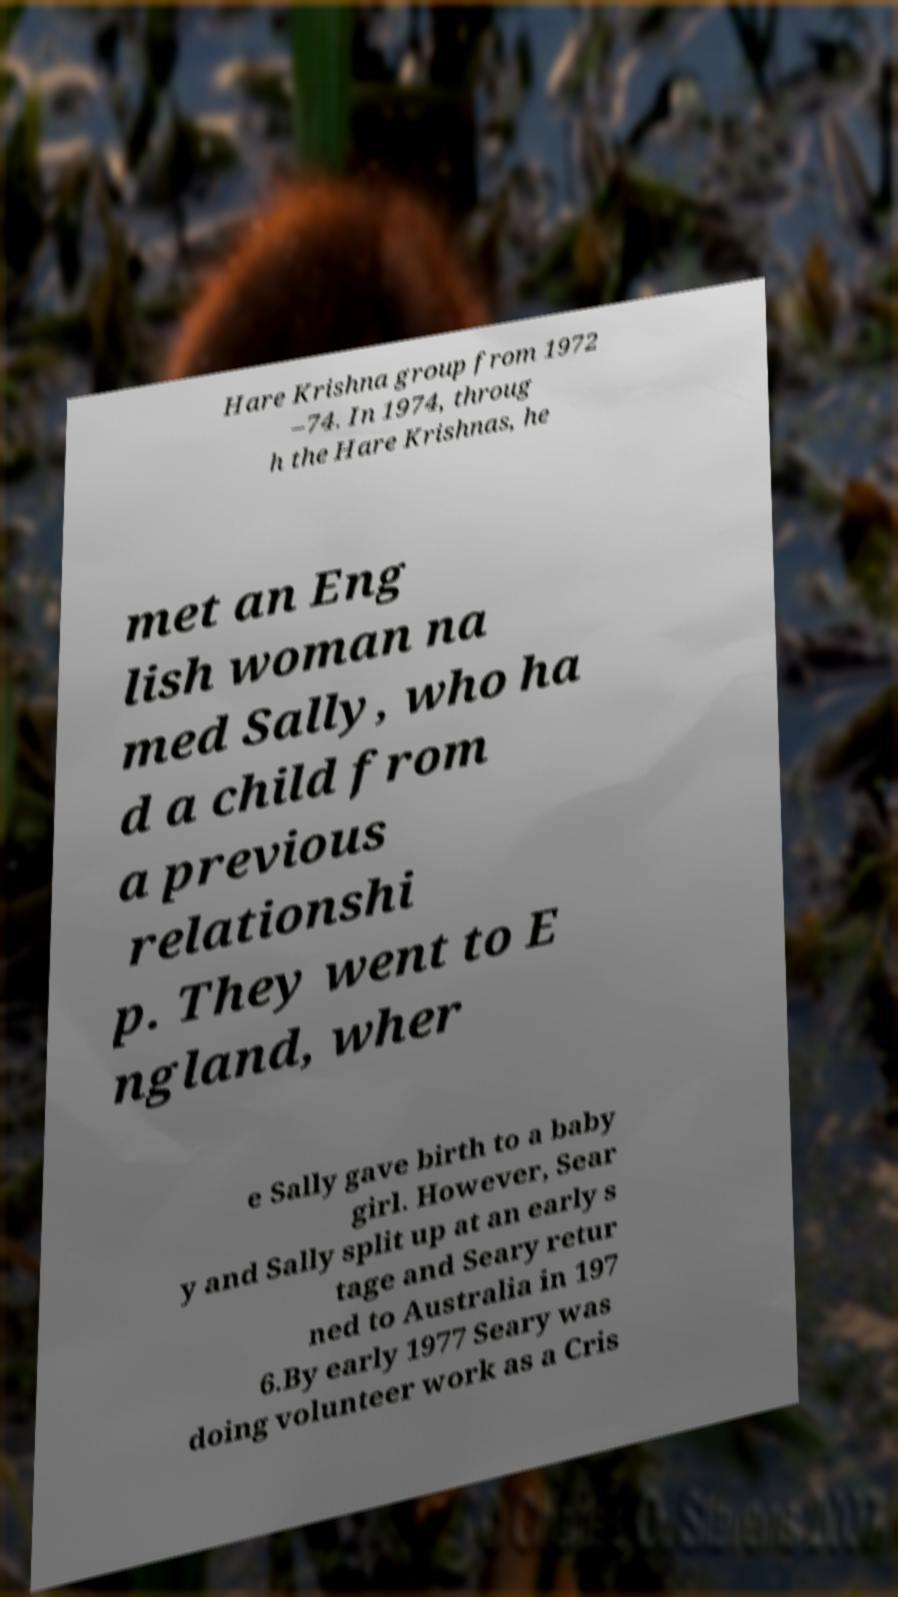Could you assist in decoding the text presented in this image and type it out clearly? Hare Krishna group from 1972 –74. In 1974, throug h the Hare Krishnas, he met an Eng lish woman na med Sally, who ha d a child from a previous relationshi p. They went to E ngland, wher e Sally gave birth to a baby girl. However, Sear y and Sally split up at an early s tage and Seary retur ned to Australia in 197 6.By early 1977 Seary was doing volunteer work as a Cris 